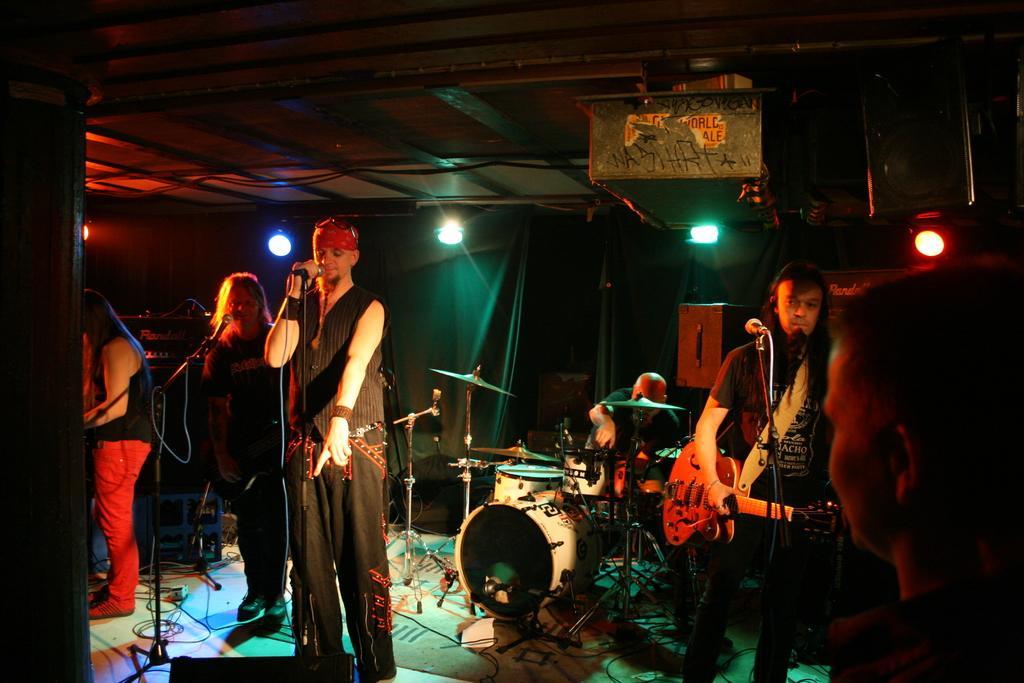Please provide a concise description of this image. In this image we can see this person is holding a guitar in his hands, this man is holding a mic in his hands, this man is sitting and playing electronic drums. In the background we can see curtains, lights and speakers. 